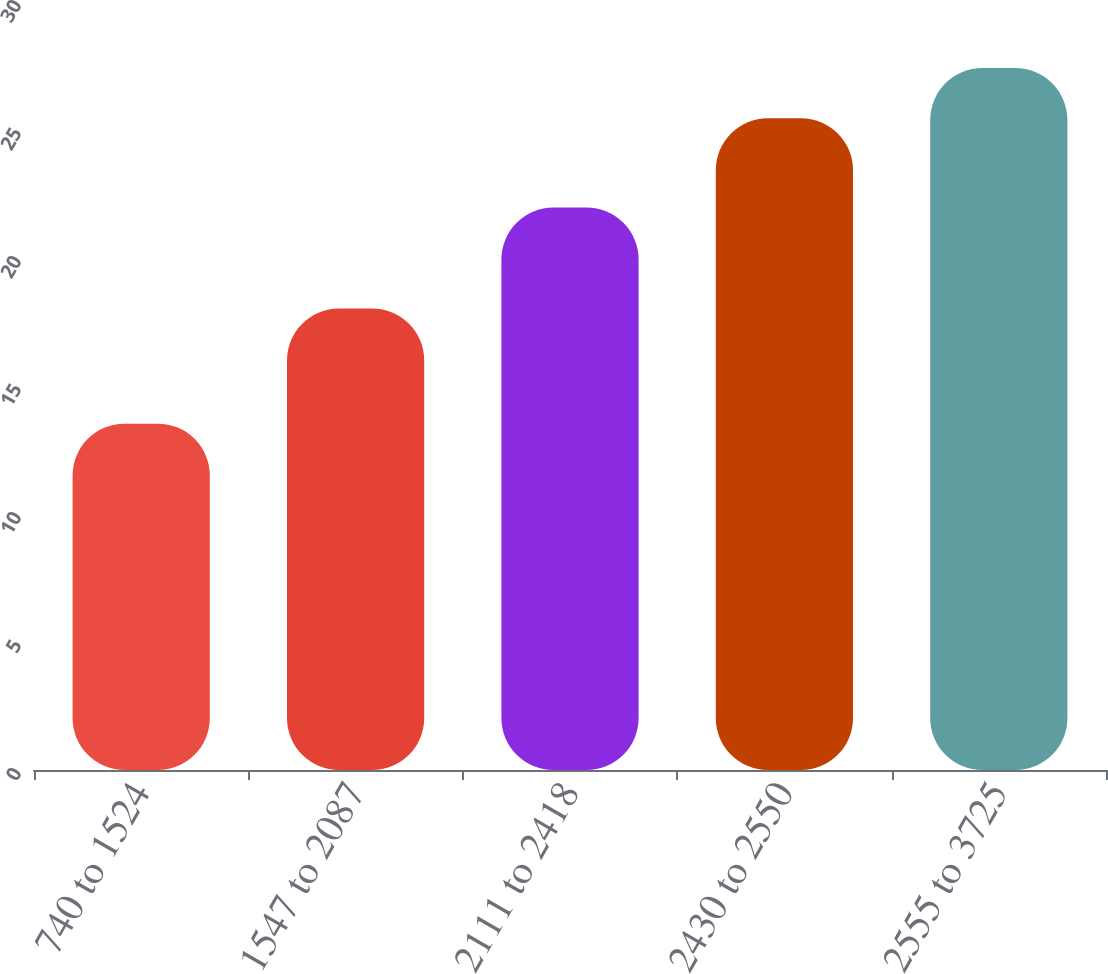Convert chart. <chart><loc_0><loc_0><loc_500><loc_500><bar_chart><fcel>740 to 1524<fcel>1547 to 2087<fcel>2111 to 2418<fcel>2430 to 2550<fcel>2555 to 3725<nl><fcel>13.53<fcel>18.03<fcel>21.97<fcel>25.46<fcel>27.42<nl></chart> 